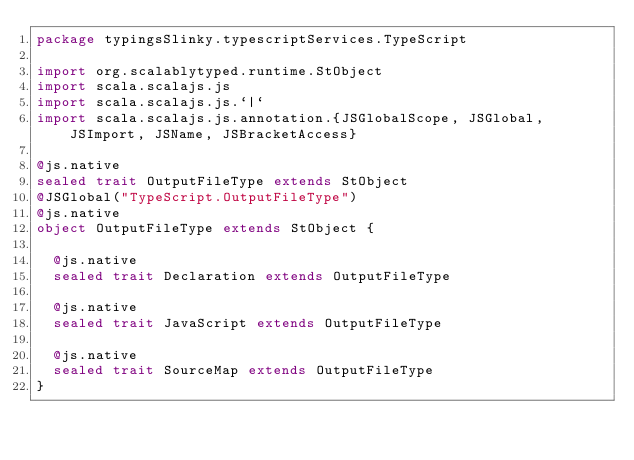<code> <loc_0><loc_0><loc_500><loc_500><_Scala_>package typingsSlinky.typescriptServices.TypeScript

import org.scalablytyped.runtime.StObject
import scala.scalajs.js
import scala.scalajs.js.`|`
import scala.scalajs.js.annotation.{JSGlobalScope, JSGlobal, JSImport, JSName, JSBracketAccess}

@js.native
sealed trait OutputFileType extends StObject
@JSGlobal("TypeScript.OutputFileType")
@js.native
object OutputFileType extends StObject {
  
  @js.native
  sealed trait Declaration extends OutputFileType
  
  @js.native
  sealed trait JavaScript extends OutputFileType
  
  @js.native
  sealed trait SourceMap extends OutputFileType
}
</code> 